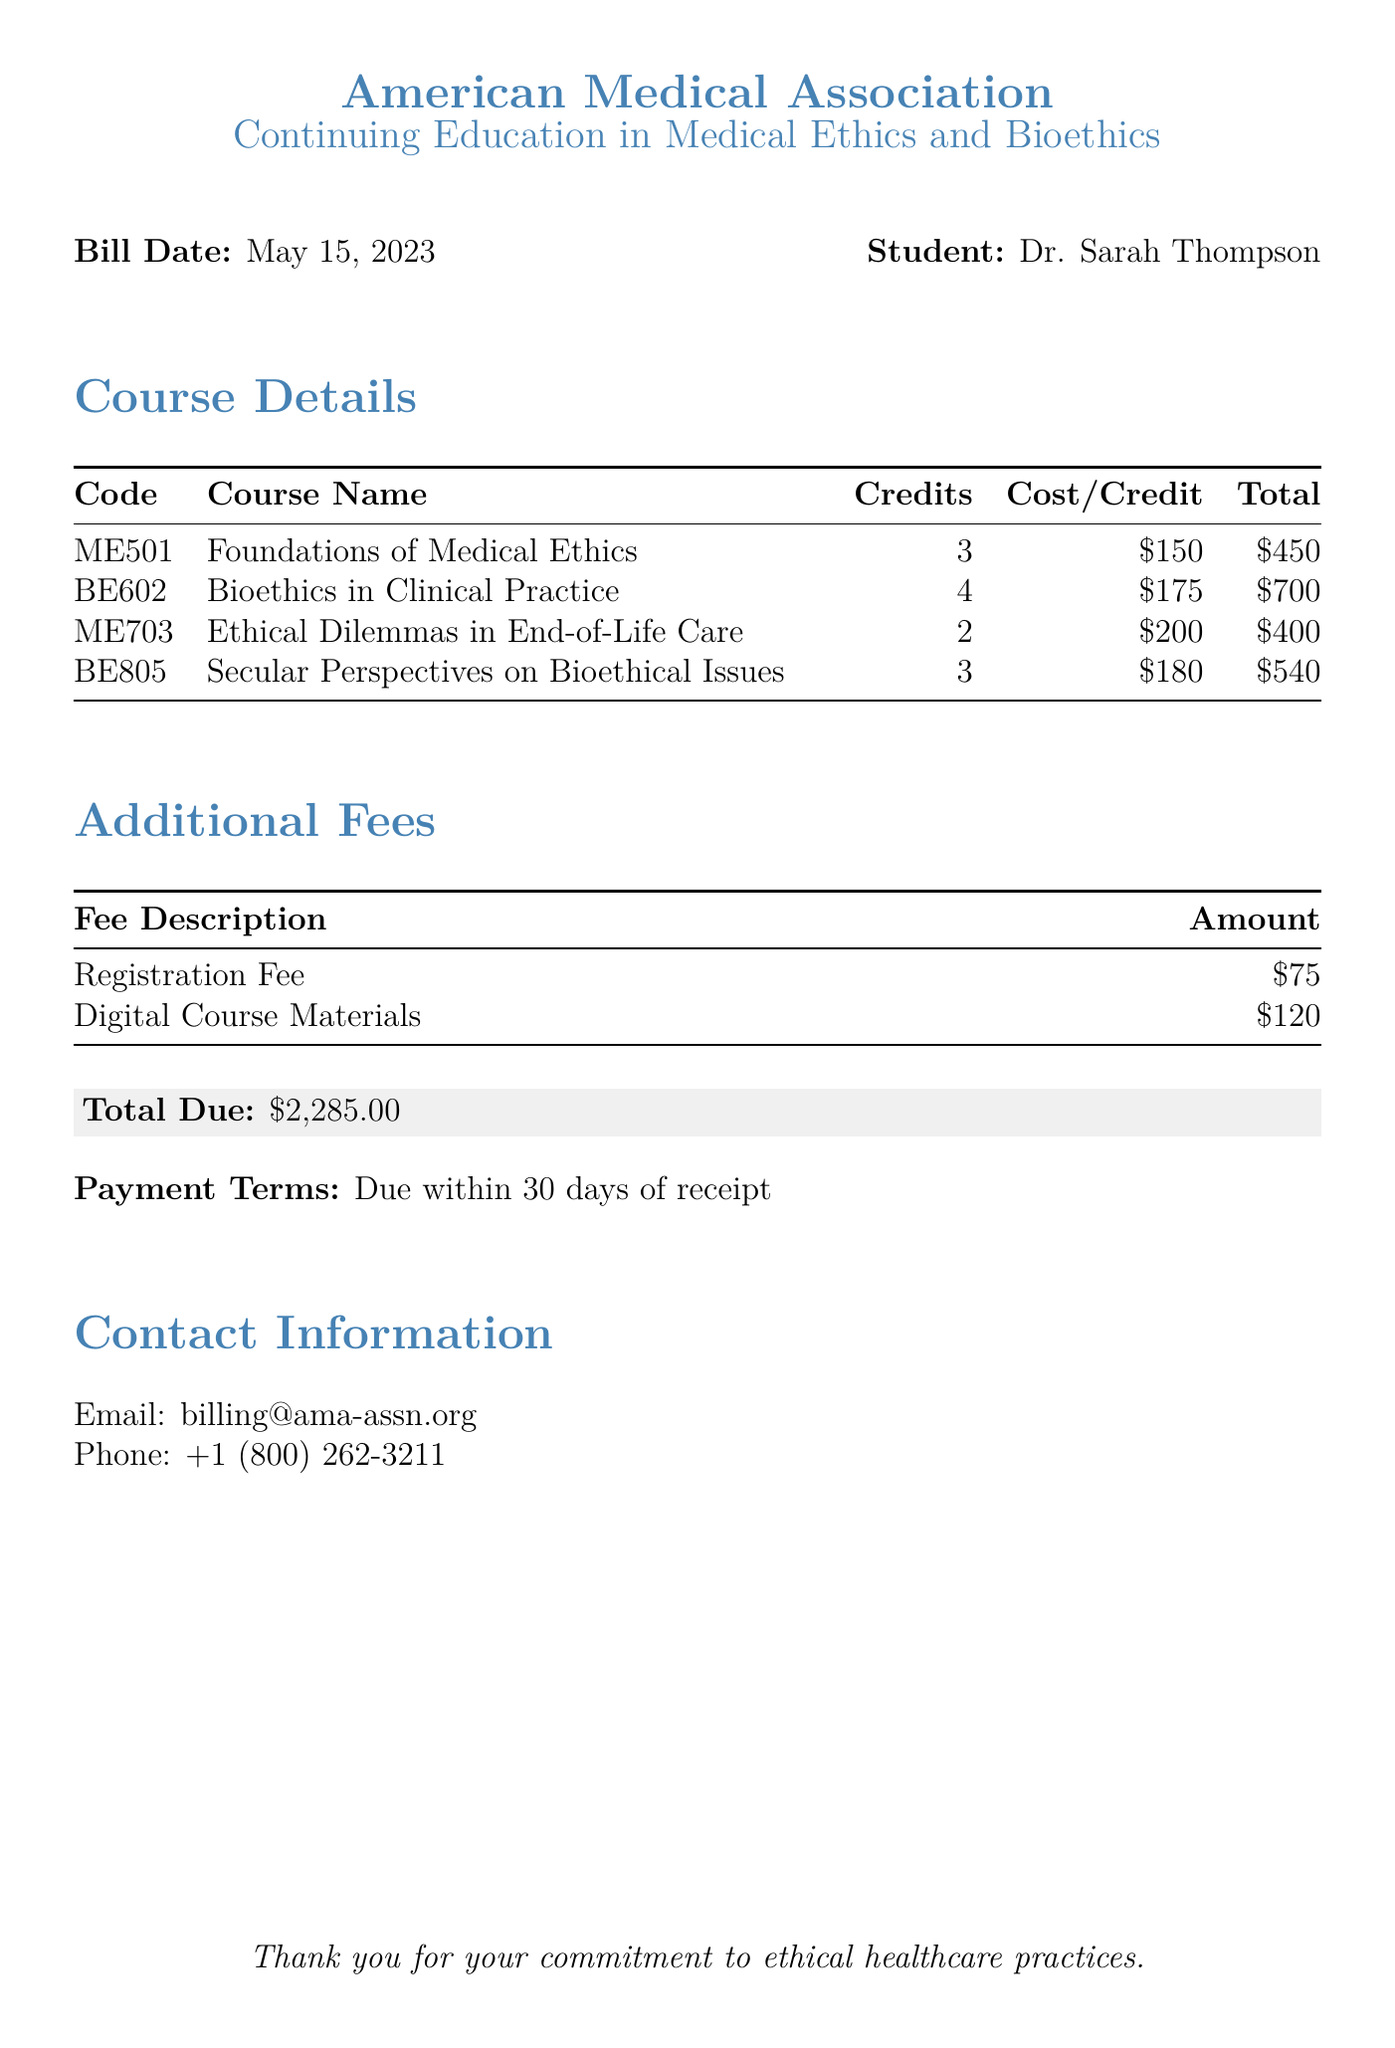What is the total amount due? The total amount due is presented in the document under "Total Due," which is explicitly stated.
Answer: $2,285.00 Who is the student listed on the bill? The document specifies the name of the student at the top, under "Student:."
Answer: Dr. Sarah Thompson What is the cost per credit for the course "Bioethics in Clinical Practice"? The cost per credit for the specified course is indicated in the table under "Cost/Credit."
Answer: $175 How many credits does the course "Ethical Dilemmas in End-of-Life Care" offer? The credits for this course are shown in the course details table under "Credits."
Answer: 2 What is the registration fee? The registration fee is listed with additional fees in the fees table.
Answer: $75 How many courses are listed in total? The total number of courses can be counted from the course details table provided in the document.
Answer: 4 What is the total cost for the course "Secular Perspectives on Bioethical Issues"? The total cost for this course is calculated based on the credits and cost per credit in the document.
Answer: $540 When is the payment due? The payment terms specify when the payment should be made, indicated in the document.
Answer: 30 days of receipt What organization is providing the continuing education? The organization responsible for the education is mentioned at the top of the document.
Answer: American Medical Association 